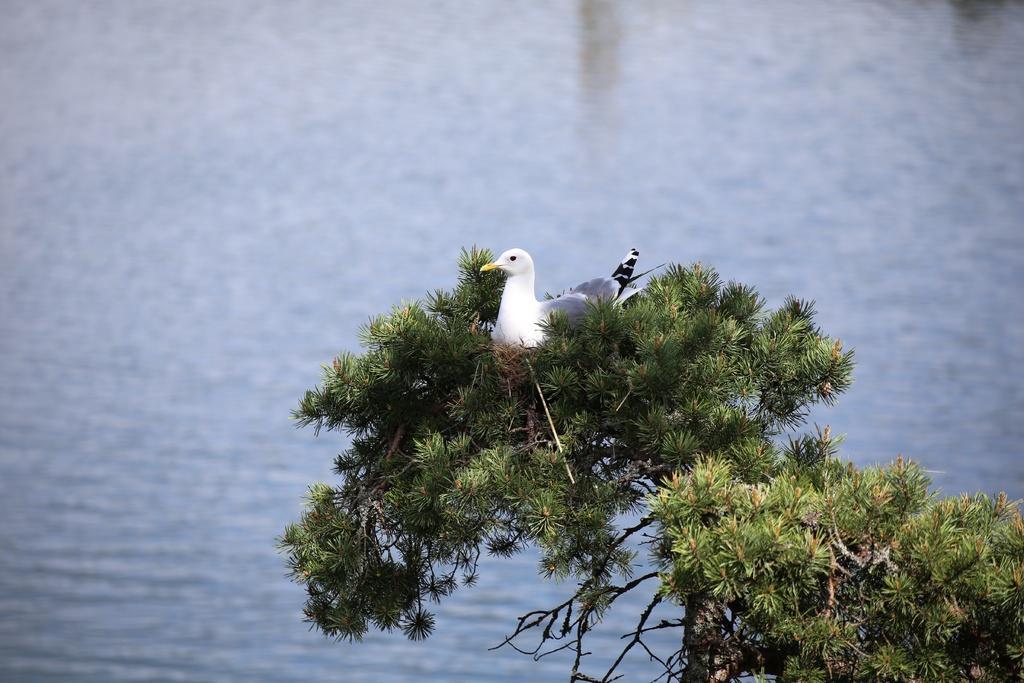Please provide a concise description of this image. In this picture we can see a bird on the tree and also we can see water. 